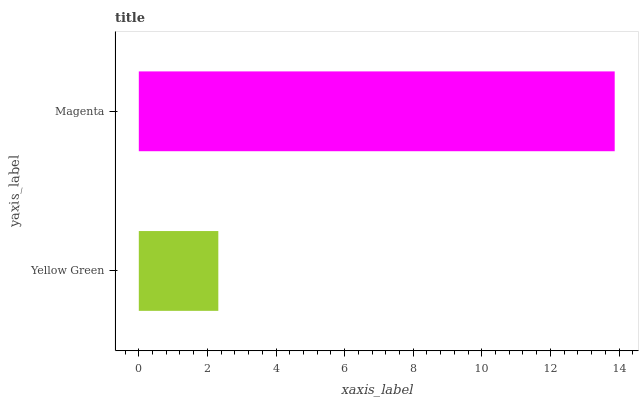Is Yellow Green the minimum?
Answer yes or no. Yes. Is Magenta the maximum?
Answer yes or no. Yes. Is Magenta the minimum?
Answer yes or no. No. Is Magenta greater than Yellow Green?
Answer yes or no. Yes. Is Yellow Green less than Magenta?
Answer yes or no. Yes. Is Yellow Green greater than Magenta?
Answer yes or no. No. Is Magenta less than Yellow Green?
Answer yes or no. No. Is Magenta the high median?
Answer yes or no. Yes. Is Yellow Green the low median?
Answer yes or no. Yes. Is Yellow Green the high median?
Answer yes or no. No. Is Magenta the low median?
Answer yes or no. No. 